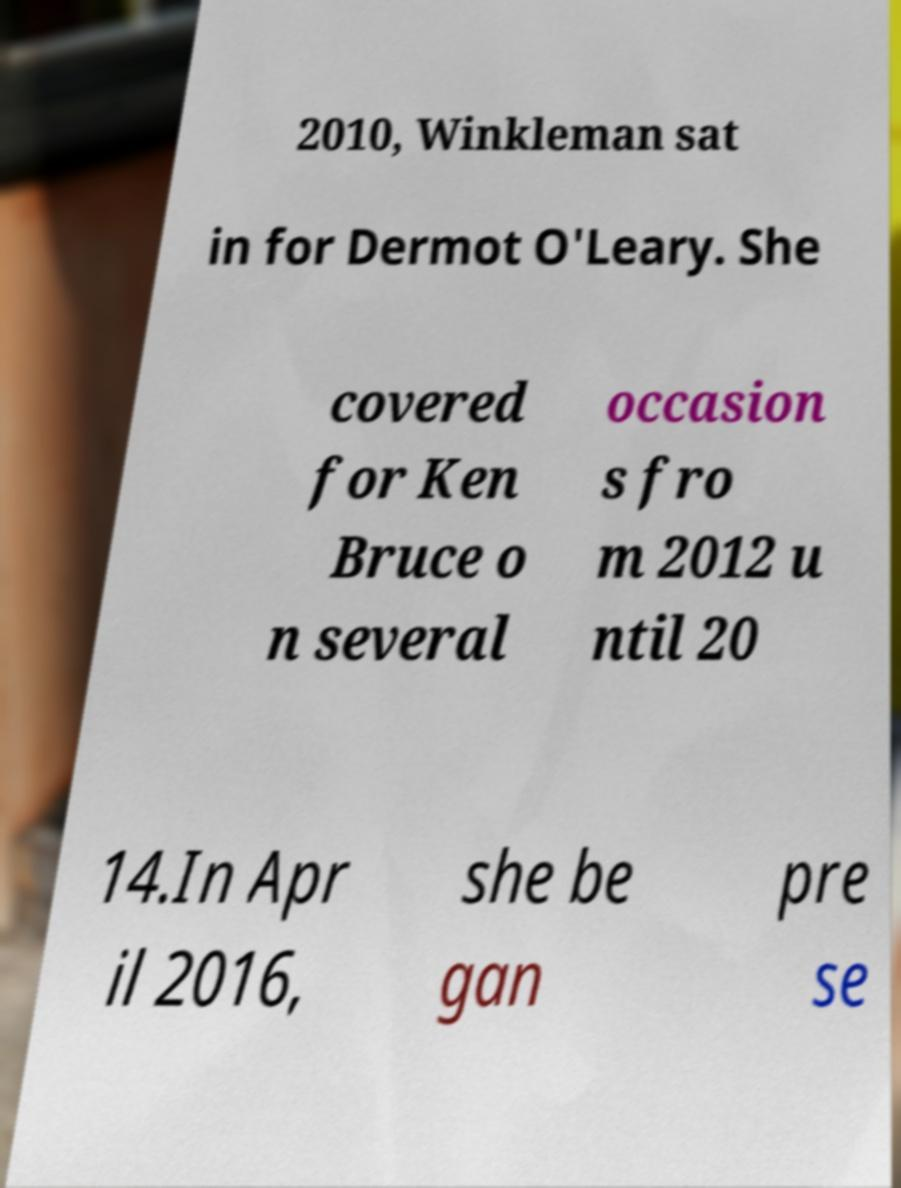What messages or text are displayed in this image? I need them in a readable, typed format. 2010, Winkleman sat in for Dermot O'Leary. She covered for Ken Bruce o n several occasion s fro m 2012 u ntil 20 14.In Apr il 2016, she be gan pre se 